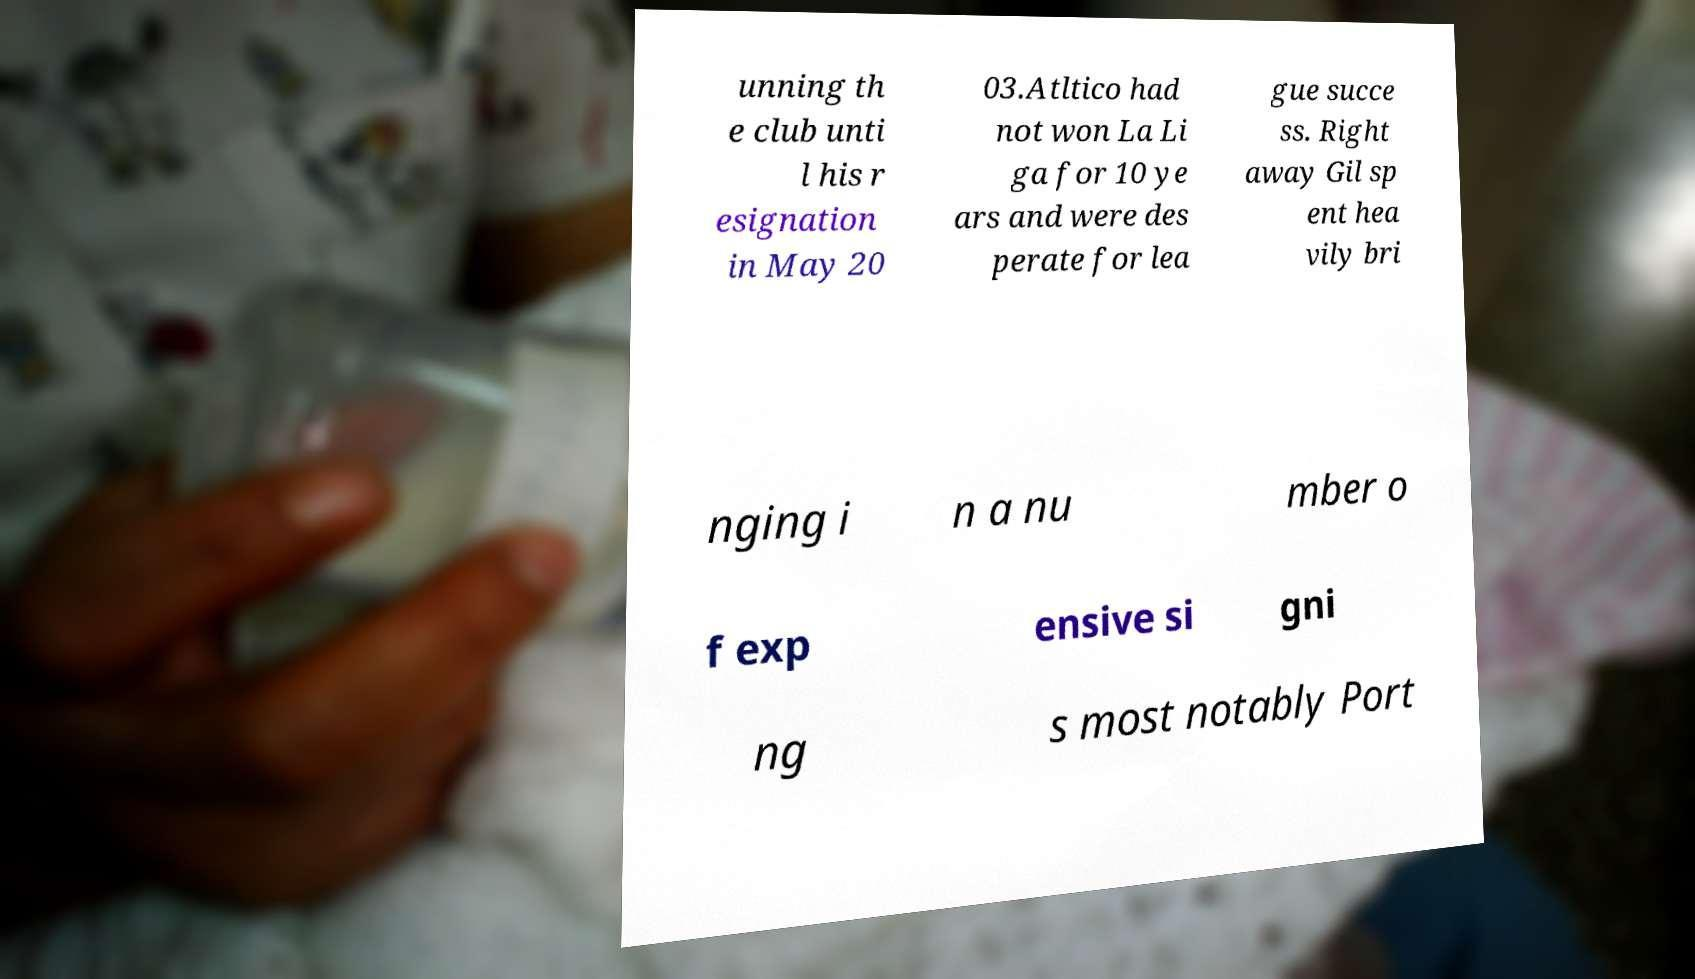What messages or text are displayed in this image? I need them in a readable, typed format. unning th e club unti l his r esignation in May 20 03.Atltico had not won La Li ga for 10 ye ars and were des perate for lea gue succe ss. Right away Gil sp ent hea vily bri nging i n a nu mber o f exp ensive si gni ng s most notably Port 